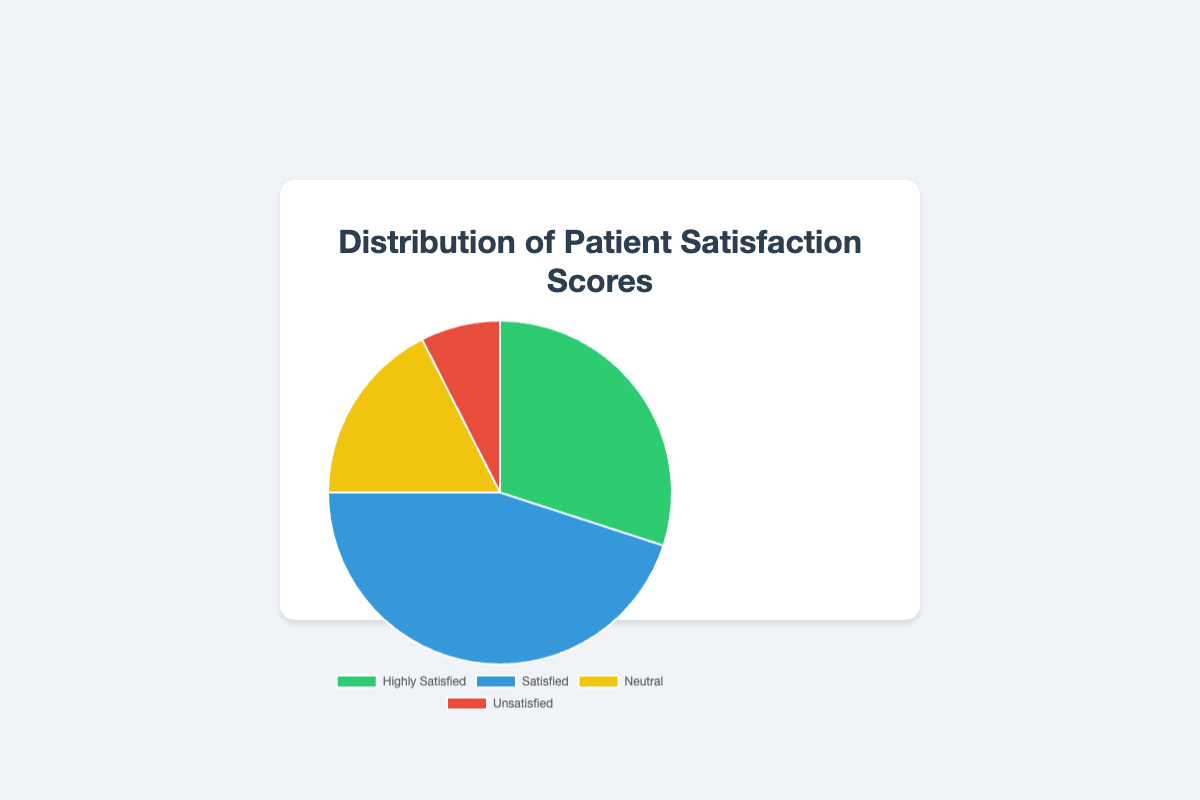How many more patients are highly satisfied compared to those who are unsatisfied? To find the difference between the number of highly satisfied and unsatisfied patients, subtract the count of unsatisfied patients from the count of highly satisfied patients, i.e., 120 - 30 = 90.
Answer: 90 What percentage of patients are either highly satisfied or satisfied? First, sum the number of highly satisfied and satisfied patients: 120 + 180 = 300. Then, calculate the total number of patients: 120 + 180 + 70 + 30 = 400. Finally, divide the sum by the total and multiply by 100 to get the percentage: (300 / 400) * 100 = 75%.
Answer: 75% Which category has the highest patient satisfaction score? By looking at the pie chart, identify the segment with the largest area. The "Satisfied" category has 180 patients, which is the highest count in the dataset.
Answer: Satisfied What is the difference in the number of patients between the Neutral and Unsatisfied categories? Subtract the count of unsatisfied patients from the count of neutral patients: 70 - 30 = 40.
Answer: 40 What is the total number of patients surveyed? Sum all the counts from each category to get the total: 120 + 180 + 70 + 30 = 400.
Answer: 400 What proportion of patients are neutral regarding their satisfaction score? Divide the number of neutral patients by the total number of patients and multiply by 100 to get the percentage: (70 / 400) * 100 = 17.5%.
Answer: 17.5% Which category has the smallest segment in the pie chart? By examining the pie chart, identify the smallest segment. The "Unsatisfied" category with 30 patients has the smallest segment.
Answer: Unsatisfied How does the number of highly satisfied patients compare to the combined number of neutral and unsatisfied patients? First, calculate the combined number of neutral and unsatisfied patients: 70 + 30 = 100. Then, compare it to the number of highly satisfied patients: 120. Since 120 > 100, the number of highly satisfied patients is greater.
Answer: Highly satisfied is greater What is the average number of patients per category? Calculate the total number of patients: 400. Then, divide this by the number of categories (4): 400 / 4 = 100.
Answer: 100 